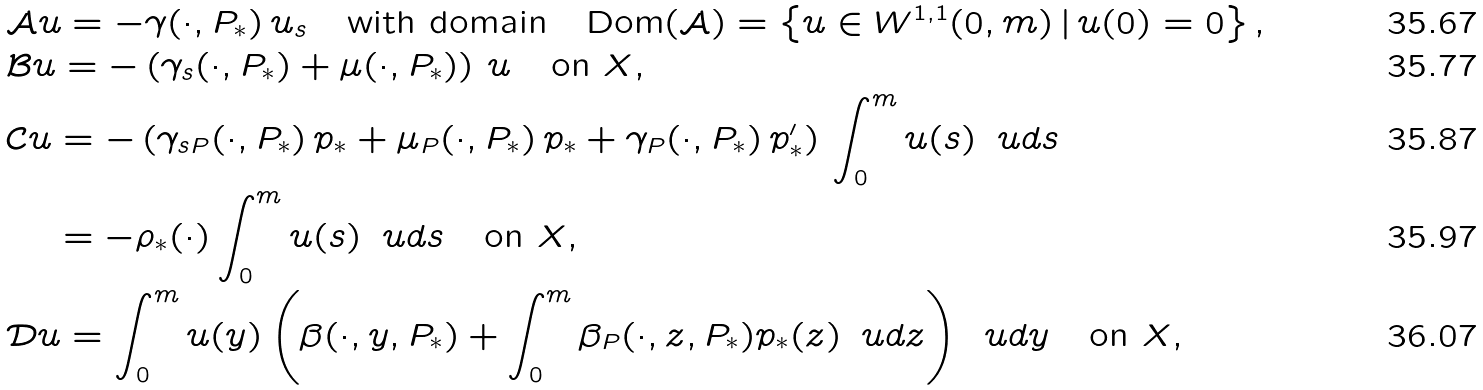Convert formula to latex. <formula><loc_0><loc_0><loc_500><loc_500>& { \mathcal { A } } u = - \gamma ( \cdot , P _ { * } ) \, u _ { s } \quad \text {with domain} \quad \text {Dom} ( { \mathcal { A } } ) = \left \{ u \in W ^ { 1 , 1 } ( 0 , m ) \, | \, u ( 0 ) = 0 \right \} , \\ & { \mathcal { B } } u = - \left ( \gamma _ { s } ( \cdot , P _ { * } ) + \mu ( \cdot , P _ { * } ) \right ) \, u \quad \text {on ${\mathcal{ }X}$,} \\ & { \mathcal { C } } u = - \left ( \gamma _ { s P } ( \cdot , P _ { * } ) \, p _ { * } + \mu _ { P } ( \cdot , P _ { * } ) \, p _ { * } + \gamma _ { P } ( \cdot , P _ { * } ) \, p _ { * } ^ { \prime } \right ) \, \int _ { 0 } ^ { m } u ( s ) \, \ u d s \\ & \quad \, = - \rho _ { * } ( \cdot ) \int _ { 0 } ^ { m } u ( s ) \, \ u d s \quad \text {on ${\mathcal{ }X}$,} \\ & { \mathcal { D } } u = \int _ { 0 } ^ { m } u ( y ) \left ( \beta ( \cdot , y , P _ { * } ) + \int _ { 0 } ^ { m } \beta _ { P } ( \cdot , z , P _ { * } ) p _ { * } ( z ) \, \ u d z \right ) \, \ u d y \quad \text {on ${\mathcal{ }X}$} ,</formula> 